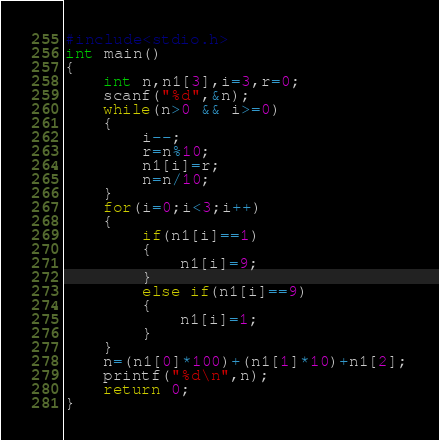Convert code to text. <code><loc_0><loc_0><loc_500><loc_500><_C_>#include<stdio.h>
int main()
{
    int n,n1[3],i=3,r=0;
    scanf("%d",&n);
    while(n>0 && i>=0)
    {
        i--;
        r=n%10;
        n1[i]=r;
        n=n/10;
    }
    for(i=0;i<3;i++)
    {
        if(n1[i]==1)
        {
            n1[i]=9;
        }
        else if(n1[i]==9)
        {
            n1[i]=1;
        }
    }
    n=(n1[0]*100)+(n1[1]*10)+n1[2];
    printf("%d\n",n);
    return 0;
}</code> 